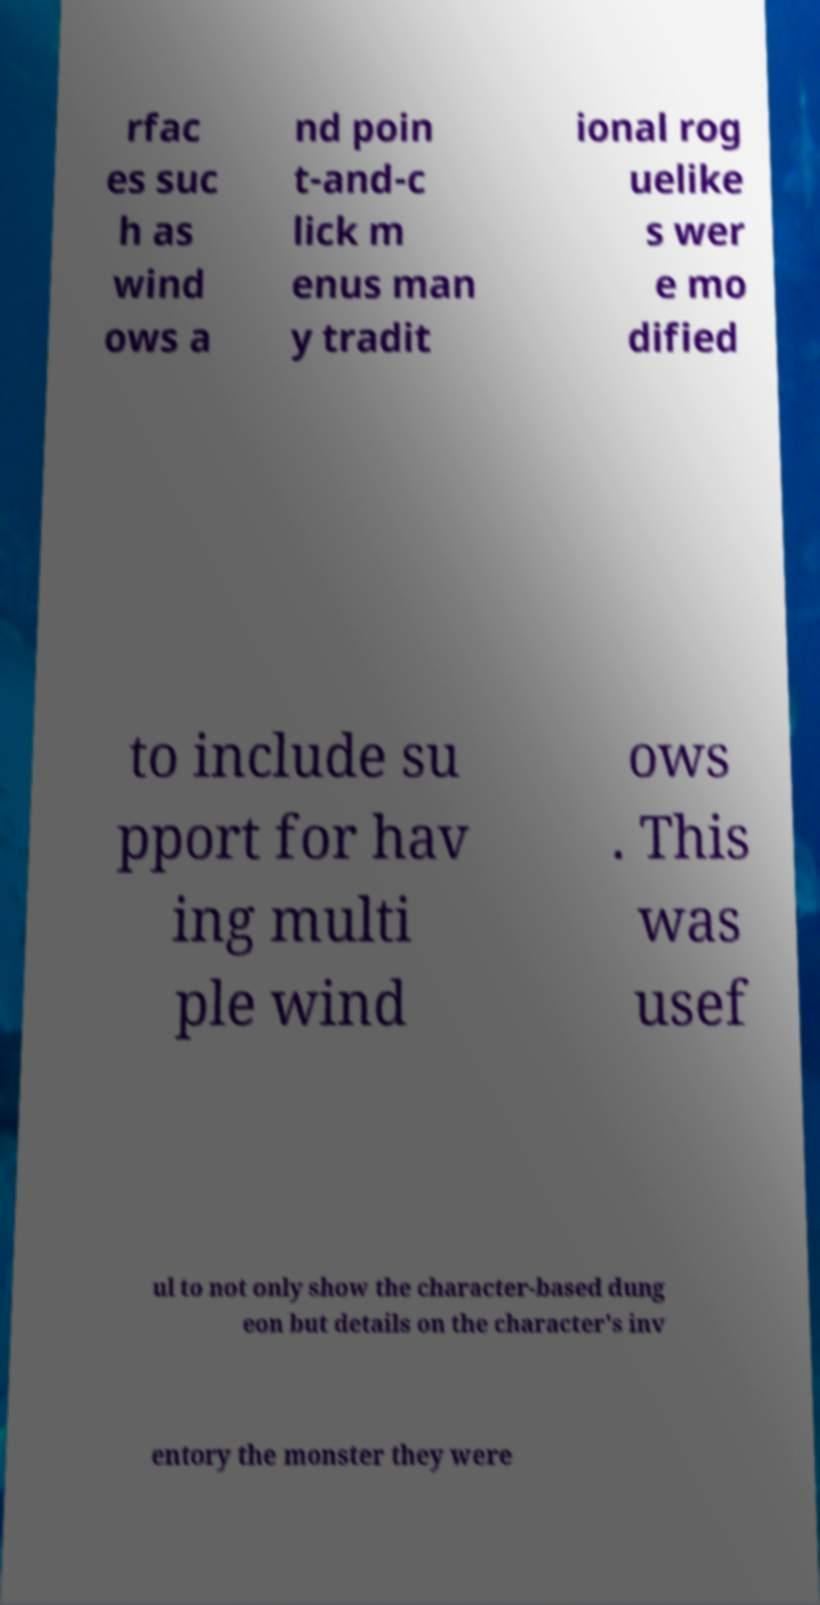Can you accurately transcribe the text from the provided image for me? rfac es suc h as wind ows a nd poin t-and-c lick m enus man y tradit ional rog uelike s wer e mo dified to include su pport for hav ing multi ple wind ows . This was usef ul to not only show the character-based dung eon but details on the character's inv entory the monster they were 